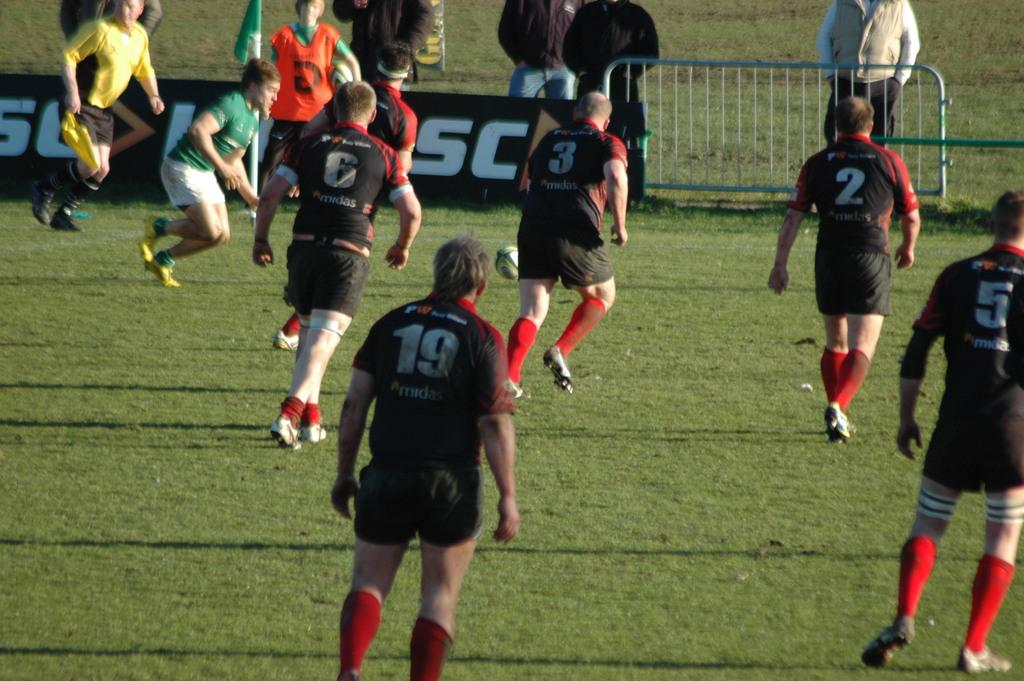What is happening in the image involving a group of people? Some people are running on the ground, while others are standing at the fence. Can you describe the setting of the image? There is grass in the background, and a flag is visible in the background as well. What might be the purpose of the fence in the image? The fence could be used to separate the area where the people are running from other parts of the location. What type of machine is being used to create the rainstorm in the image? There is no rainstorm or machine present in the image. 